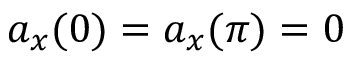Convert formula to latex. <formula><loc_0><loc_0><loc_500><loc_500>a _ { x } ( 0 ) = a _ { x } ( \pi ) = 0</formula> 